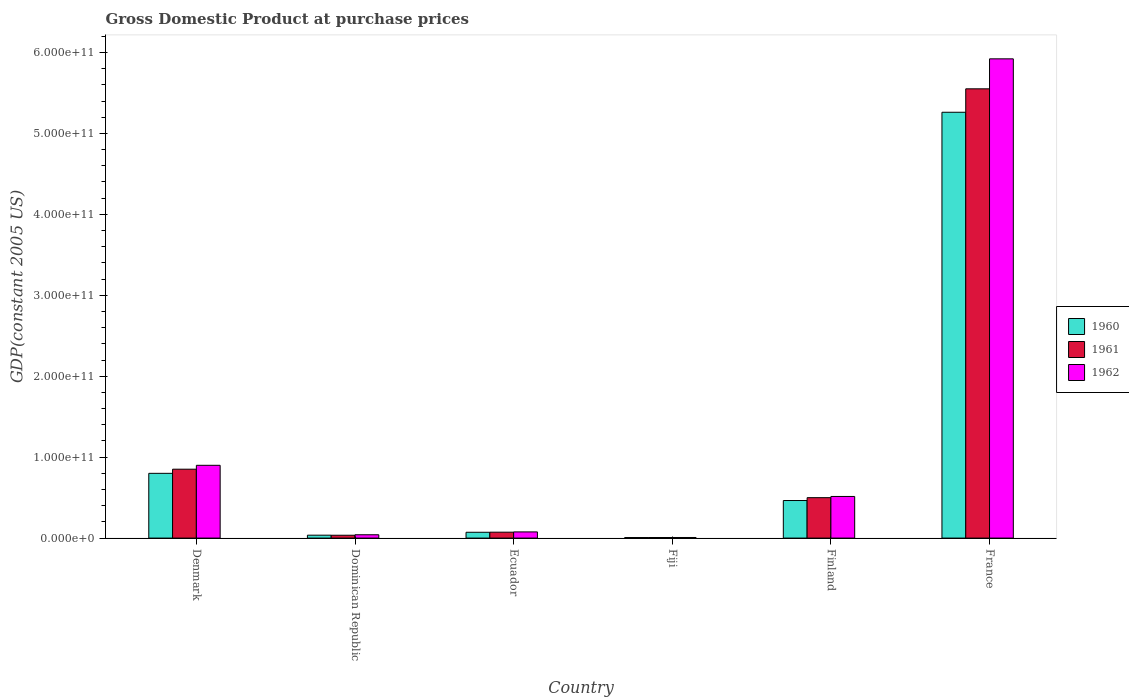How many different coloured bars are there?
Ensure brevity in your answer.  3. How many groups of bars are there?
Give a very brief answer. 6. Are the number of bars on each tick of the X-axis equal?
Your answer should be compact. Yes. What is the label of the 2nd group of bars from the left?
Keep it short and to the point. Dominican Republic. In how many cases, is the number of bars for a given country not equal to the number of legend labels?
Your response must be concise. 0. What is the GDP at purchase prices in 1962 in Finland?
Your response must be concise. 5.14e+1. Across all countries, what is the maximum GDP at purchase prices in 1961?
Keep it short and to the point. 5.55e+11. Across all countries, what is the minimum GDP at purchase prices in 1962?
Provide a succinct answer. 7.42e+08. In which country was the GDP at purchase prices in 1962 maximum?
Make the answer very short. France. In which country was the GDP at purchase prices in 1962 minimum?
Your answer should be compact. Fiji. What is the total GDP at purchase prices in 1962 in the graph?
Give a very brief answer. 7.46e+11. What is the difference between the GDP at purchase prices in 1961 in Dominican Republic and that in Fiji?
Provide a succinct answer. 2.80e+09. What is the difference between the GDP at purchase prices in 1960 in France and the GDP at purchase prices in 1961 in Fiji?
Provide a short and direct response. 5.25e+11. What is the average GDP at purchase prices in 1962 per country?
Ensure brevity in your answer.  1.24e+11. What is the difference between the GDP at purchase prices of/in 1961 and GDP at purchase prices of/in 1960 in Fiji?
Give a very brief answer. 2.43e+07. In how many countries, is the GDP at purchase prices in 1962 greater than 540000000000 US$?
Give a very brief answer. 1. What is the ratio of the GDP at purchase prices in 1961 in Denmark to that in Fiji?
Keep it short and to the point. 118.79. Is the GDP at purchase prices in 1961 in Denmark less than that in Dominican Republic?
Provide a short and direct response. No. Is the difference between the GDP at purchase prices in 1961 in Denmark and France greater than the difference between the GDP at purchase prices in 1960 in Denmark and France?
Give a very brief answer. No. What is the difference between the highest and the second highest GDP at purchase prices in 1960?
Your answer should be compact. 4.80e+11. What is the difference between the highest and the lowest GDP at purchase prices in 1961?
Offer a very short reply. 5.54e+11. In how many countries, is the GDP at purchase prices in 1962 greater than the average GDP at purchase prices in 1962 taken over all countries?
Provide a succinct answer. 1. What does the 3rd bar from the right in Dominican Republic represents?
Give a very brief answer. 1960. Is it the case that in every country, the sum of the GDP at purchase prices in 1961 and GDP at purchase prices in 1962 is greater than the GDP at purchase prices in 1960?
Keep it short and to the point. Yes. How many countries are there in the graph?
Offer a very short reply. 6. What is the difference between two consecutive major ticks on the Y-axis?
Keep it short and to the point. 1.00e+11. Does the graph contain any zero values?
Your response must be concise. No. What is the title of the graph?
Offer a very short reply. Gross Domestic Product at purchase prices. What is the label or title of the Y-axis?
Offer a terse response. GDP(constant 2005 US). What is the GDP(constant 2005 US) in 1960 in Denmark?
Your response must be concise. 8.00e+1. What is the GDP(constant 2005 US) in 1961 in Denmark?
Your response must be concise. 8.51e+1. What is the GDP(constant 2005 US) in 1962 in Denmark?
Your response must be concise. 8.99e+1. What is the GDP(constant 2005 US) of 1960 in Dominican Republic?
Provide a succinct answer. 3.60e+09. What is the GDP(constant 2005 US) of 1961 in Dominican Republic?
Ensure brevity in your answer.  3.51e+09. What is the GDP(constant 2005 US) of 1962 in Dominican Republic?
Give a very brief answer. 4.11e+09. What is the GDP(constant 2005 US) in 1960 in Ecuador?
Offer a terse response. 7.19e+09. What is the GDP(constant 2005 US) in 1961 in Ecuador?
Make the answer very short. 7.30e+09. What is the GDP(constant 2005 US) in 1962 in Ecuador?
Your answer should be compact. 7.64e+09. What is the GDP(constant 2005 US) in 1960 in Fiji?
Offer a very short reply. 6.92e+08. What is the GDP(constant 2005 US) of 1961 in Fiji?
Give a very brief answer. 7.17e+08. What is the GDP(constant 2005 US) in 1962 in Fiji?
Offer a very short reply. 7.42e+08. What is the GDP(constant 2005 US) in 1960 in Finland?
Keep it short and to the point. 4.64e+1. What is the GDP(constant 2005 US) in 1961 in Finland?
Offer a terse response. 4.99e+1. What is the GDP(constant 2005 US) in 1962 in Finland?
Keep it short and to the point. 5.14e+1. What is the GDP(constant 2005 US) of 1960 in France?
Provide a short and direct response. 5.26e+11. What is the GDP(constant 2005 US) of 1961 in France?
Provide a succinct answer. 5.55e+11. What is the GDP(constant 2005 US) in 1962 in France?
Keep it short and to the point. 5.92e+11. Across all countries, what is the maximum GDP(constant 2005 US) of 1960?
Provide a succinct answer. 5.26e+11. Across all countries, what is the maximum GDP(constant 2005 US) of 1961?
Your response must be concise. 5.55e+11. Across all countries, what is the maximum GDP(constant 2005 US) in 1962?
Provide a short and direct response. 5.92e+11. Across all countries, what is the minimum GDP(constant 2005 US) in 1960?
Your answer should be compact. 6.92e+08. Across all countries, what is the minimum GDP(constant 2005 US) of 1961?
Provide a succinct answer. 7.17e+08. Across all countries, what is the minimum GDP(constant 2005 US) of 1962?
Ensure brevity in your answer.  7.42e+08. What is the total GDP(constant 2005 US) in 1960 in the graph?
Your answer should be very brief. 6.64e+11. What is the total GDP(constant 2005 US) of 1961 in the graph?
Provide a short and direct response. 7.02e+11. What is the total GDP(constant 2005 US) of 1962 in the graph?
Offer a terse response. 7.46e+11. What is the difference between the GDP(constant 2005 US) in 1960 in Denmark and that in Dominican Republic?
Make the answer very short. 7.64e+1. What is the difference between the GDP(constant 2005 US) in 1961 in Denmark and that in Dominican Republic?
Your answer should be very brief. 8.16e+1. What is the difference between the GDP(constant 2005 US) in 1962 in Denmark and that in Dominican Republic?
Ensure brevity in your answer.  8.58e+1. What is the difference between the GDP(constant 2005 US) of 1960 in Denmark and that in Ecuador?
Provide a succinct answer. 7.28e+1. What is the difference between the GDP(constant 2005 US) in 1961 in Denmark and that in Ecuador?
Your answer should be compact. 7.78e+1. What is the difference between the GDP(constant 2005 US) of 1962 in Denmark and that in Ecuador?
Offer a very short reply. 8.23e+1. What is the difference between the GDP(constant 2005 US) of 1960 in Denmark and that in Fiji?
Give a very brief answer. 7.93e+1. What is the difference between the GDP(constant 2005 US) in 1961 in Denmark and that in Fiji?
Your answer should be very brief. 8.44e+1. What is the difference between the GDP(constant 2005 US) of 1962 in Denmark and that in Fiji?
Make the answer very short. 8.92e+1. What is the difference between the GDP(constant 2005 US) in 1960 in Denmark and that in Finland?
Offer a terse response. 3.36e+1. What is the difference between the GDP(constant 2005 US) in 1961 in Denmark and that in Finland?
Give a very brief answer. 3.52e+1. What is the difference between the GDP(constant 2005 US) of 1962 in Denmark and that in Finland?
Give a very brief answer. 3.85e+1. What is the difference between the GDP(constant 2005 US) in 1960 in Denmark and that in France?
Your answer should be compact. -4.46e+11. What is the difference between the GDP(constant 2005 US) of 1961 in Denmark and that in France?
Provide a succinct answer. -4.70e+11. What is the difference between the GDP(constant 2005 US) in 1962 in Denmark and that in France?
Your answer should be very brief. -5.02e+11. What is the difference between the GDP(constant 2005 US) in 1960 in Dominican Republic and that in Ecuador?
Make the answer very short. -3.59e+09. What is the difference between the GDP(constant 2005 US) of 1961 in Dominican Republic and that in Ecuador?
Your answer should be very brief. -3.79e+09. What is the difference between the GDP(constant 2005 US) of 1962 in Dominican Republic and that in Ecuador?
Offer a very short reply. -3.52e+09. What is the difference between the GDP(constant 2005 US) in 1960 in Dominican Republic and that in Fiji?
Provide a succinct answer. 2.91e+09. What is the difference between the GDP(constant 2005 US) in 1961 in Dominican Republic and that in Fiji?
Your response must be concise. 2.80e+09. What is the difference between the GDP(constant 2005 US) of 1962 in Dominican Republic and that in Fiji?
Provide a succinct answer. 3.37e+09. What is the difference between the GDP(constant 2005 US) in 1960 in Dominican Republic and that in Finland?
Offer a very short reply. -4.28e+1. What is the difference between the GDP(constant 2005 US) of 1961 in Dominican Republic and that in Finland?
Your answer should be compact. -4.64e+1. What is the difference between the GDP(constant 2005 US) of 1962 in Dominican Republic and that in Finland?
Keep it short and to the point. -4.73e+1. What is the difference between the GDP(constant 2005 US) in 1960 in Dominican Republic and that in France?
Ensure brevity in your answer.  -5.23e+11. What is the difference between the GDP(constant 2005 US) of 1961 in Dominican Republic and that in France?
Your answer should be very brief. -5.52e+11. What is the difference between the GDP(constant 2005 US) of 1962 in Dominican Republic and that in France?
Make the answer very short. -5.88e+11. What is the difference between the GDP(constant 2005 US) in 1960 in Ecuador and that in Fiji?
Provide a succinct answer. 6.50e+09. What is the difference between the GDP(constant 2005 US) of 1961 in Ecuador and that in Fiji?
Your answer should be very brief. 6.59e+09. What is the difference between the GDP(constant 2005 US) of 1962 in Ecuador and that in Fiji?
Ensure brevity in your answer.  6.89e+09. What is the difference between the GDP(constant 2005 US) in 1960 in Ecuador and that in Finland?
Provide a short and direct response. -3.92e+1. What is the difference between the GDP(constant 2005 US) of 1961 in Ecuador and that in Finland?
Provide a succinct answer. -4.26e+1. What is the difference between the GDP(constant 2005 US) in 1962 in Ecuador and that in Finland?
Offer a very short reply. -4.38e+1. What is the difference between the GDP(constant 2005 US) in 1960 in Ecuador and that in France?
Give a very brief answer. -5.19e+11. What is the difference between the GDP(constant 2005 US) in 1961 in Ecuador and that in France?
Make the answer very short. -5.48e+11. What is the difference between the GDP(constant 2005 US) in 1962 in Ecuador and that in France?
Make the answer very short. -5.85e+11. What is the difference between the GDP(constant 2005 US) in 1960 in Fiji and that in Finland?
Keep it short and to the point. -4.57e+1. What is the difference between the GDP(constant 2005 US) in 1961 in Fiji and that in Finland?
Make the answer very short. -4.92e+1. What is the difference between the GDP(constant 2005 US) of 1962 in Fiji and that in Finland?
Keep it short and to the point. -5.07e+1. What is the difference between the GDP(constant 2005 US) in 1960 in Fiji and that in France?
Keep it short and to the point. -5.25e+11. What is the difference between the GDP(constant 2005 US) of 1961 in Fiji and that in France?
Provide a succinct answer. -5.54e+11. What is the difference between the GDP(constant 2005 US) in 1962 in Fiji and that in France?
Your answer should be compact. -5.91e+11. What is the difference between the GDP(constant 2005 US) in 1960 in Finland and that in France?
Offer a very short reply. -4.80e+11. What is the difference between the GDP(constant 2005 US) in 1961 in Finland and that in France?
Provide a short and direct response. -5.05e+11. What is the difference between the GDP(constant 2005 US) in 1962 in Finland and that in France?
Provide a succinct answer. -5.41e+11. What is the difference between the GDP(constant 2005 US) of 1960 in Denmark and the GDP(constant 2005 US) of 1961 in Dominican Republic?
Keep it short and to the point. 7.65e+1. What is the difference between the GDP(constant 2005 US) of 1960 in Denmark and the GDP(constant 2005 US) of 1962 in Dominican Republic?
Your answer should be very brief. 7.59e+1. What is the difference between the GDP(constant 2005 US) in 1961 in Denmark and the GDP(constant 2005 US) in 1962 in Dominican Republic?
Offer a very short reply. 8.10e+1. What is the difference between the GDP(constant 2005 US) in 1960 in Denmark and the GDP(constant 2005 US) in 1961 in Ecuador?
Make the answer very short. 7.27e+1. What is the difference between the GDP(constant 2005 US) in 1960 in Denmark and the GDP(constant 2005 US) in 1962 in Ecuador?
Your response must be concise. 7.24e+1. What is the difference between the GDP(constant 2005 US) in 1961 in Denmark and the GDP(constant 2005 US) in 1962 in Ecuador?
Make the answer very short. 7.75e+1. What is the difference between the GDP(constant 2005 US) of 1960 in Denmark and the GDP(constant 2005 US) of 1961 in Fiji?
Provide a short and direct response. 7.93e+1. What is the difference between the GDP(constant 2005 US) in 1960 in Denmark and the GDP(constant 2005 US) in 1962 in Fiji?
Your response must be concise. 7.93e+1. What is the difference between the GDP(constant 2005 US) in 1961 in Denmark and the GDP(constant 2005 US) in 1962 in Fiji?
Make the answer very short. 8.44e+1. What is the difference between the GDP(constant 2005 US) in 1960 in Denmark and the GDP(constant 2005 US) in 1961 in Finland?
Your response must be concise. 3.01e+1. What is the difference between the GDP(constant 2005 US) in 1960 in Denmark and the GDP(constant 2005 US) in 1962 in Finland?
Offer a terse response. 2.86e+1. What is the difference between the GDP(constant 2005 US) in 1961 in Denmark and the GDP(constant 2005 US) in 1962 in Finland?
Your answer should be compact. 3.37e+1. What is the difference between the GDP(constant 2005 US) in 1960 in Denmark and the GDP(constant 2005 US) in 1961 in France?
Make the answer very short. -4.75e+11. What is the difference between the GDP(constant 2005 US) in 1960 in Denmark and the GDP(constant 2005 US) in 1962 in France?
Provide a short and direct response. -5.12e+11. What is the difference between the GDP(constant 2005 US) of 1961 in Denmark and the GDP(constant 2005 US) of 1962 in France?
Your answer should be compact. -5.07e+11. What is the difference between the GDP(constant 2005 US) of 1960 in Dominican Republic and the GDP(constant 2005 US) of 1961 in Ecuador?
Offer a terse response. -3.71e+09. What is the difference between the GDP(constant 2005 US) in 1960 in Dominican Republic and the GDP(constant 2005 US) in 1962 in Ecuador?
Ensure brevity in your answer.  -4.04e+09. What is the difference between the GDP(constant 2005 US) in 1961 in Dominican Republic and the GDP(constant 2005 US) in 1962 in Ecuador?
Give a very brief answer. -4.12e+09. What is the difference between the GDP(constant 2005 US) in 1960 in Dominican Republic and the GDP(constant 2005 US) in 1961 in Fiji?
Offer a very short reply. 2.88e+09. What is the difference between the GDP(constant 2005 US) in 1960 in Dominican Republic and the GDP(constant 2005 US) in 1962 in Fiji?
Your response must be concise. 2.86e+09. What is the difference between the GDP(constant 2005 US) in 1961 in Dominican Republic and the GDP(constant 2005 US) in 1962 in Fiji?
Your answer should be very brief. 2.77e+09. What is the difference between the GDP(constant 2005 US) of 1960 in Dominican Republic and the GDP(constant 2005 US) of 1961 in Finland?
Provide a succinct answer. -4.63e+1. What is the difference between the GDP(constant 2005 US) of 1960 in Dominican Republic and the GDP(constant 2005 US) of 1962 in Finland?
Ensure brevity in your answer.  -4.78e+1. What is the difference between the GDP(constant 2005 US) in 1961 in Dominican Republic and the GDP(constant 2005 US) in 1962 in Finland?
Ensure brevity in your answer.  -4.79e+1. What is the difference between the GDP(constant 2005 US) in 1960 in Dominican Republic and the GDP(constant 2005 US) in 1961 in France?
Your answer should be compact. -5.52e+11. What is the difference between the GDP(constant 2005 US) of 1960 in Dominican Republic and the GDP(constant 2005 US) of 1962 in France?
Provide a short and direct response. -5.89e+11. What is the difference between the GDP(constant 2005 US) in 1961 in Dominican Republic and the GDP(constant 2005 US) in 1962 in France?
Offer a very short reply. -5.89e+11. What is the difference between the GDP(constant 2005 US) of 1960 in Ecuador and the GDP(constant 2005 US) of 1961 in Fiji?
Keep it short and to the point. 6.48e+09. What is the difference between the GDP(constant 2005 US) of 1960 in Ecuador and the GDP(constant 2005 US) of 1962 in Fiji?
Your answer should be compact. 6.45e+09. What is the difference between the GDP(constant 2005 US) in 1961 in Ecuador and the GDP(constant 2005 US) in 1962 in Fiji?
Keep it short and to the point. 6.56e+09. What is the difference between the GDP(constant 2005 US) of 1960 in Ecuador and the GDP(constant 2005 US) of 1961 in Finland?
Your response must be concise. -4.28e+1. What is the difference between the GDP(constant 2005 US) in 1960 in Ecuador and the GDP(constant 2005 US) in 1962 in Finland?
Offer a terse response. -4.42e+1. What is the difference between the GDP(constant 2005 US) of 1961 in Ecuador and the GDP(constant 2005 US) of 1962 in Finland?
Your answer should be very brief. -4.41e+1. What is the difference between the GDP(constant 2005 US) in 1960 in Ecuador and the GDP(constant 2005 US) in 1961 in France?
Provide a succinct answer. -5.48e+11. What is the difference between the GDP(constant 2005 US) of 1960 in Ecuador and the GDP(constant 2005 US) of 1962 in France?
Ensure brevity in your answer.  -5.85e+11. What is the difference between the GDP(constant 2005 US) of 1961 in Ecuador and the GDP(constant 2005 US) of 1962 in France?
Make the answer very short. -5.85e+11. What is the difference between the GDP(constant 2005 US) of 1960 in Fiji and the GDP(constant 2005 US) of 1961 in Finland?
Provide a succinct answer. -4.93e+1. What is the difference between the GDP(constant 2005 US) of 1960 in Fiji and the GDP(constant 2005 US) of 1962 in Finland?
Make the answer very short. -5.07e+1. What is the difference between the GDP(constant 2005 US) in 1961 in Fiji and the GDP(constant 2005 US) in 1962 in Finland?
Provide a short and direct response. -5.07e+1. What is the difference between the GDP(constant 2005 US) of 1960 in Fiji and the GDP(constant 2005 US) of 1961 in France?
Your answer should be very brief. -5.54e+11. What is the difference between the GDP(constant 2005 US) of 1960 in Fiji and the GDP(constant 2005 US) of 1962 in France?
Give a very brief answer. -5.91e+11. What is the difference between the GDP(constant 2005 US) in 1961 in Fiji and the GDP(constant 2005 US) in 1962 in France?
Your answer should be very brief. -5.91e+11. What is the difference between the GDP(constant 2005 US) in 1960 in Finland and the GDP(constant 2005 US) in 1961 in France?
Give a very brief answer. -5.09e+11. What is the difference between the GDP(constant 2005 US) of 1960 in Finland and the GDP(constant 2005 US) of 1962 in France?
Your response must be concise. -5.46e+11. What is the difference between the GDP(constant 2005 US) in 1961 in Finland and the GDP(constant 2005 US) in 1962 in France?
Keep it short and to the point. -5.42e+11. What is the average GDP(constant 2005 US) of 1960 per country?
Keep it short and to the point. 1.11e+11. What is the average GDP(constant 2005 US) of 1961 per country?
Ensure brevity in your answer.  1.17e+11. What is the average GDP(constant 2005 US) of 1962 per country?
Offer a very short reply. 1.24e+11. What is the difference between the GDP(constant 2005 US) of 1960 and GDP(constant 2005 US) of 1961 in Denmark?
Make the answer very short. -5.10e+09. What is the difference between the GDP(constant 2005 US) in 1960 and GDP(constant 2005 US) in 1962 in Denmark?
Make the answer very short. -9.93e+09. What is the difference between the GDP(constant 2005 US) of 1961 and GDP(constant 2005 US) of 1962 in Denmark?
Your answer should be compact. -4.82e+09. What is the difference between the GDP(constant 2005 US) in 1960 and GDP(constant 2005 US) in 1961 in Dominican Republic?
Make the answer very short. 8.32e+07. What is the difference between the GDP(constant 2005 US) in 1960 and GDP(constant 2005 US) in 1962 in Dominican Republic?
Provide a succinct answer. -5.16e+08. What is the difference between the GDP(constant 2005 US) in 1961 and GDP(constant 2005 US) in 1962 in Dominican Republic?
Offer a very short reply. -5.99e+08. What is the difference between the GDP(constant 2005 US) in 1960 and GDP(constant 2005 US) in 1961 in Ecuador?
Offer a terse response. -1.11e+08. What is the difference between the GDP(constant 2005 US) of 1960 and GDP(constant 2005 US) of 1962 in Ecuador?
Make the answer very short. -4.44e+08. What is the difference between the GDP(constant 2005 US) in 1961 and GDP(constant 2005 US) in 1962 in Ecuador?
Your response must be concise. -3.33e+08. What is the difference between the GDP(constant 2005 US) of 1960 and GDP(constant 2005 US) of 1961 in Fiji?
Ensure brevity in your answer.  -2.43e+07. What is the difference between the GDP(constant 2005 US) of 1960 and GDP(constant 2005 US) of 1962 in Fiji?
Offer a terse response. -5.02e+07. What is the difference between the GDP(constant 2005 US) in 1961 and GDP(constant 2005 US) in 1962 in Fiji?
Provide a short and direct response. -2.58e+07. What is the difference between the GDP(constant 2005 US) in 1960 and GDP(constant 2005 US) in 1961 in Finland?
Ensure brevity in your answer.  -3.53e+09. What is the difference between the GDP(constant 2005 US) in 1960 and GDP(constant 2005 US) in 1962 in Finland?
Offer a terse response. -5.02e+09. What is the difference between the GDP(constant 2005 US) in 1961 and GDP(constant 2005 US) in 1962 in Finland?
Make the answer very short. -1.49e+09. What is the difference between the GDP(constant 2005 US) in 1960 and GDP(constant 2005 US) in 1961 in France?
Offer a terse response. -2.90e+1. What is the difference between the GDP(constant 2005 US) in 1960 and GDP(constant 2005 US) in 1962 in France?
Provide a succinct answer. -6.60e+1. What is the difference between the GDP(constant 2005 US) in 1961 and GDP(constant 2005 US) in 1962 in France?
Your answer should be compact. -3.70e+1. What is the ratio of the GDP(constant 2005 US) in 1960 in Denmark to that in Dominican Republic?
Provide a short and direct response. 22.24. What is the ratio of the GDP(constant 2005 US) in 1961 in Denmark to that in Dominican Republic?
Your response must be concise. 24.22. What is the ratio of the GDP(constant 2005 US) in 1962 in Denmark to that in Dominican Republic?
Keep it short and to the point. 21.86. What is the ratio of the GDP(constant 2005 US) of 1960 in Denmark to that in Ecuador?
Your answer should be compact. 11.12. What is the ratio of the GDP(constant 2005 US) of 1961 in Denmark to that in Ecuador?
Ensure brevity in your answer.  11.65. What is the ratio of the GDP(constant 2005 US) of 1962 in Denmark to that in Ecuador?
Give a very brief answer. 11.78. What is the ratio of the GDP(constant 2005 US) in 1960 in Denmark to that in Fiji?
Provide a succinct answer. 115.6. What is the ratio of the GDP(constant 2005 US) in 1961 in Denmark to that in Fiji?
Provide a short and direct response. 118.79. What is the ratio of the GDP(constant 2005 US) in 1962 in Denmark to that in Fiji?
Your response must be concise. 121.16. What is the ratio of the GDP(constant 2005 US) of 1960 in Denmark to that in Finland?
Offer a very short reply. 1.72. What is the ratio of the GDP(constant 2005 US) in 1961 in Denmark to that in Finland?
Give a very brief answer. 1.7. What is the ratio of the GDP(constant 2005 US) of 1962 in Denmark to that in Finland?
Ensure brevity in your answer.  1.75. What is the ratio of the GDP(constant 2005 US) in 1960 in Denmark to that in France?
Offer a very short reply. 0.15. What is the ratio of the GDP(constant 2005 US) of 1961 in Denmark to that in France?
Provide a succinct answer. 0.15. What is the ratio of the GDP(constant 2005 US) of 1962 in Denmark to that in France?
Make the answer very short. 0.15. What is the ratio of the GDP(constant 2005 US) in 1960 in Dominican Republic to that in Ecuador?
Provide a short and direct response. 0.5. What is the ratio of the GDP(constant 2005 US) of 1961 in Dominican Republic to that in Ecuador?
Provide a succinct answer. 0.48. What is the ratio of the GDP(constant 2005 US) in 1962 in Dominican Republic to that in Ecuador?
Ensure brevity in your answer.  0.54. What is the ratio of the GDP(constant 2005 US) in 1960 in Dominican Republic to that in Fiji?
Provide a succinct answer. 5.2. What is the ratio of the GDP(constant 2005 US) of 1961 in Dominican Republic to that in Fiji?
Provide a short and direct response. 4.9. What is the ratio of the GDP(constant 2005 US) in 1962 in Dominican Republic to that in Fiji?
Give a very brief answer. 5.54. What is the ratio of the GDP(constant 2005 US) of 1960 in Dominican Republic to that in Finland?
Your answer should be compact. 0.08. What is the ratio of the GDP(constant 2005 US) in 1961 in Dominican Republic to that in Finland?
Your answer should be compact. 0.07. What is the ratio of the GDP(constant 2005 US) of 1960 in Dominican Republic to that in France?
Your answer should be compact. 0.01. What is the ratio of the GDP(constant 2005 US) in 1961 in Dominican Republic to that in France?
Your answer should be compact. 0.01. What is the ratio of the GDP(constant 2005 US) in 1962 in Dominican Republic to that in France?
Ensure brevity in your answer.  0.01. What is the ratio of the GDP(constant 2005 US) of 1960 in Ecuador to that in Fiji?
Your answer should be compact. 10.39. What is the ratio of the GDP(constant 2005 US) in 1961 in Ecuador to that in Fiji?
Make the answer very short. 10.19. What is the ratio of the GDP(constant 2005 US) of 1962 in Ecuador to that in Fiji?
Your answer should be very brief. 10.29. What is the ratio of the GDP(constant 2005 US) of 1960 in Ecuador to that in Finland?
Make the answer very short. 0.15. What is the ratio of the GDP(constant 2005 US) in 1961 in Ecuador to that in Finland?
Your answer should be compact. 0.15. What is the ratio of the GDP(constant 2005 US) of 1962 in Ecuador to that in Finland?
Provide a short and direct response. 0.15. What is the ratio of the GDP(constant 2005 US) of 1960 in Ecuador to that in France?
Ensure brevity in your answer.  0.01. What is the ratio of the GDP(constant 2005 US) in 1961 in Ecuador to that in France?
Ensure brevity in your answer.  0.01. What is the ratio of the GDP(constant 2005 US) in 1962 in Ecuador to that in France?
Keep it short and to the point. 0.01. What is the ratio of the GDP(constant 2005 US) of 1960 in Fiji to that in Finland?
Give a very brief answer. 0.01. What is the ratio of the GDP(constant 2005 US) of 1961 in Fiji to that in Finland?
Your answer should be very brief. 0.01. What is the ratio of the GDP(constant 2005 US) in 1962 in Fiji to that in Finland?
Give a very brief answer. 0.01. What is the ratio of the GDP(constant 2005 US) of 1960 in Fiji to that in France?
Your answer should be very brief. 0. What is the ratio of the GDP(constant 2005 US) of 1961 in Fiji to that in France?
Give a very brief answer. 0. What is the ratio of the GDP(constant 2005 US) of 1962 in Fiji to that in France?
Provide a short and direct response. 0. What is the ratio of the GDP(constant 2005 US) in 1960 in Finland to that in France?
Ensure brevity in your answer.  0.09. What is the ratio of the GDP(constant 2005 US) of 1961 in Finland to that in France?
Ensure brevity in your answer.  0.09. What is the ratio of the GDP(constant 2005 US) in 1962 in Finland to that in France?
Provide a short and direct response. 0.09. What is the difference between the highest and the second highest GDP(constant 2005 US) of 1960?
Provide a succinct answer. 4.46e+11. What is the difference between the highest and the second highest GDP(constant 2005 US) in 1961?
Offer a very short reply. 4.70e+11. What is the difference between the highest and the second highest GDP(constant 2005 US) in 1962?
Your response must be concise. 5.02e+11. What is the difference between the highest and the lowest GDP(constant 2005 US) of 1960?
Keep it short and to the point. 5.25e+11. What is the difference between the highest and the lowest GDP(constant 2005 US) in 1961?
Provide a succinct answer. 5.54e+11. What is the difference between the highest and the lowest GDP(constant 2005 US) of 1962?
Offer a very short reply. 5.91e+11. 